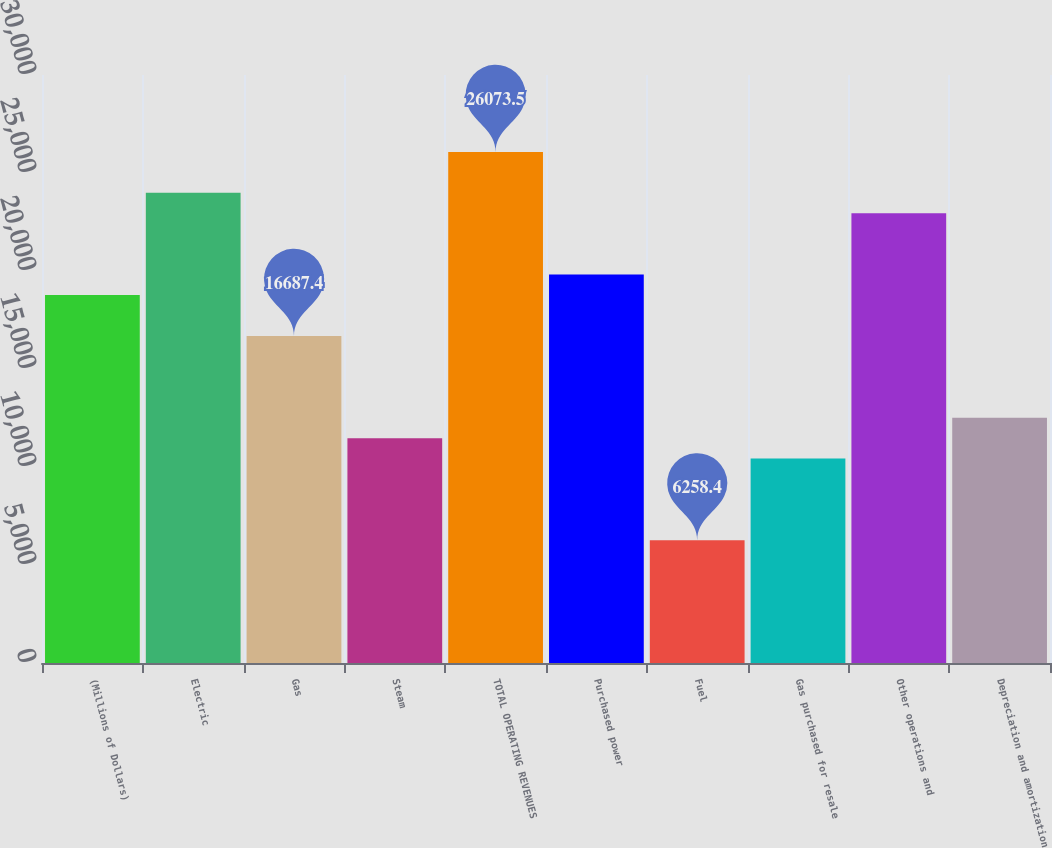<chart> <loc_0><loc_0><loc_500><loc_500><bar_chart><fcel>(Millions of Dollars)<fcel>Electric<fcel>Gas<fcel>Steam<fcel>TOTAL OPERATING REVENUES<fcel>Purchased power<fcel>Fuel<fcel>Gas purchased for resale<fcel>Other operations and<fcel>Depreciation and amortization<nl><fcel>18773.2<fcel>23987.7<fcel>16687.4<fcel>11472.9<fcel>26073.5<fcel>19816.1<fcel>6258.4<fcel>10430<fcel>22944.8<fcel>12515.8<nl></chart> 